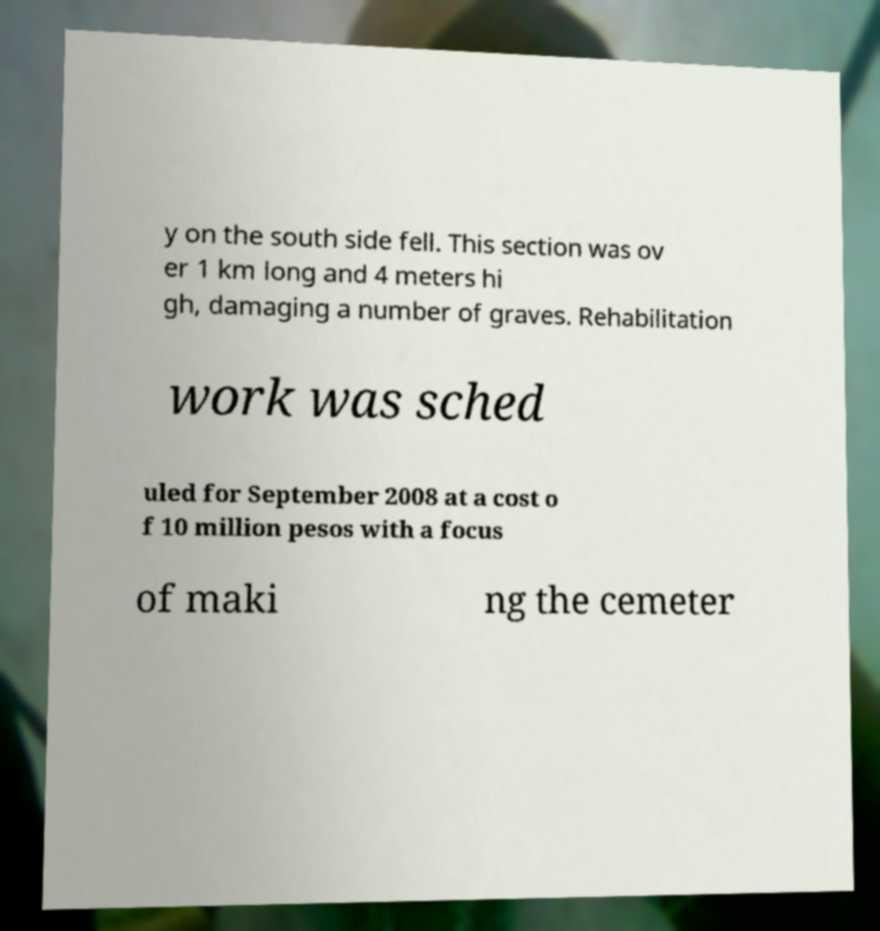Can you read and provide the text displayed in the image?This photo seems to have some interesting text. Can you extract and type it out for me? y on the south side fell. This section was ov er 1 km long and 4 meters hi gh, damaging a number of graves. Rehabilitation work was sched uled for September 2008 at a cost o f 10 million pesos with a focus of maki ng the cemeter 